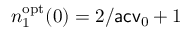<formula> <loc_0><loc_0><loc_500><loc_500>n _ { 1 } ^ { o p t } ( 0 ) = 2 / a c v _ { 0 } + 1</formula> 